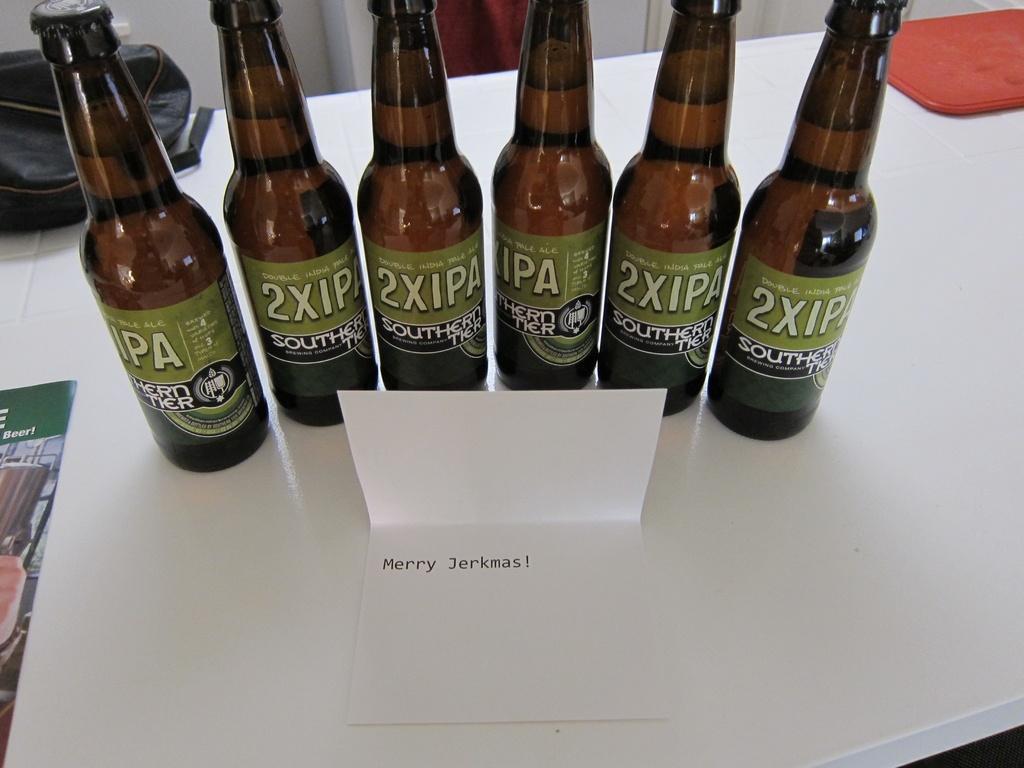Could you give a brief overview of what you see in this image? There are six bottles on the table and a paper note named as merry sharkmas in front of them and a bag is there. 